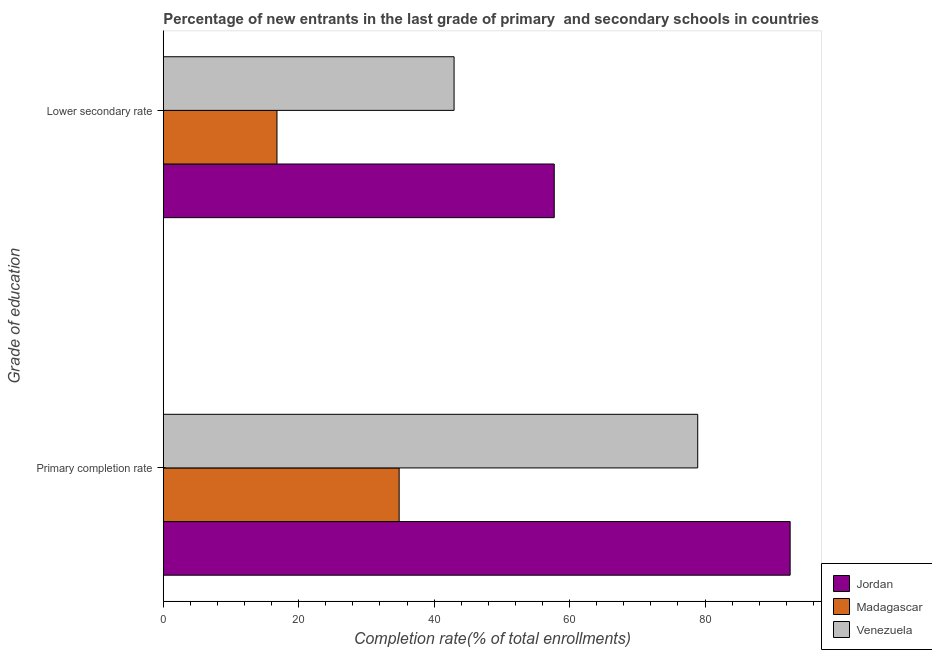How many groups of bars are there?
Provide a short and direct response. 2. What is the label of the 2nd group of bars from the top?
Give a very brief answer. Primary completion rate. What is the completion rate in secondary schools in Madagascar?
Ensure brevity in your answer.  16.79. Across all countries, what is the maximum completion rate in secondary schools?
Offer a terse response. 57.74. Across all countries, what is the minimum completion rate in secondary schools?
Your response must be concise. 16.79. In which country was the completion rate in secondary schools maximum?
Provide a short and direct response. Jordan. In which country was the completion rate in secondary schools minimum?
Ensure brevity in your answer.  Madagascar. What is the total completion rate in secondary schools in the graph?
Offer a terse response. 117.48. What is the difference between the completion rate in primary schools in Jordan and that in Madagascar?
Ensure brevity in your answer.  57.74. What is the difference between the completion rate in primary schools in Jordan and the completion rate in secondary schools in Venezuela?
Keep it short and to the point. 49.63. What is the average completion rate in primary schools per country?
Provide a succinct answer. 68.78. What is the difference between the completion rate in primary schools and completion rate in secondary schools in Venezuela?
Your response must be concise. 35.98. What is the ratio of the completion rate in primary schools in Madagascar to that in Jordan?
Give a very brief answer. 0.38. What does the 2nd bar from the top in Lower secondary rate represents?
Ensure brevity in your answer.  Madagascar. What does the 3rd bar from the bottom in Lower secondary rate represents?
Provide a short and direct response. Venezuela. How many bars are there?
Ensure brevity in your answer.  6. What is the difference between two consecutive major ticks on the X-axis?
Provide a succinct answer. 20. Are the values on the major ticks of X-axis written in scientific E-notation?
Provide a succinct answer. No. Does the graph contain any zero values?
Your answer should be compact. No. How are the legend labels stacked?
Your answer should be compact. Vertical. What is the title of the graph?
Provide a short and direct response. Percentage of new entrants in the last grade of primary  and secondary schools in countries. What is the label or title of the X-axis?
Ensure brevity in your answer.  Completion rate(% of total enrollments). What is the label or title of the Y-axis?
Your answer should be very brief. Grade of education. What is the Completion rate(% of total enrollments) in Jordan in Primary completion rate?
Your response must be concise. 92.57. What is the Completion rate(% of total enrollments) in Madagascar in Primary completion rate?
Your answer should be compact. 34.84. What is the Completion rate(% of total enrollments) in Venezuela in Primary completion rate?
Ensure brevity in your answer.  78.92. What is the Completion rate(% of total enrollments) of Jordan in Lower secondary rate?
Give a very brief answer. 57.74. What is the Completion rate(% of total enrollments) of Madagascar in Lower secondary rate?
Offer a very short reply. 16.79. What is the Completion rate(% of total enrollments) of Venezuela in Lower secondary rate?
Ensure brevity in your answer.  42.94. Across all Grade of education, what is the maximum Completion rate(% of total enrollments) of Jordan?
Provide a succinct answer. 92.57. Across all Grade of education, what is the maximum Completion rate(% of total enrollments) of Madagascar?
Make the answer very short. 34.84. Across all Grade of education, what is the maximum Completion rate(% of total enrollments) in Venezuela?
Ensure brevity in your answer.  78.92. Across all Grade of education, what is the minimum Completion rate(% of total enrollments) of Jordan?
Ensure brevity in your answer.  57.74. Across all Grade of education, what is the minimum Completion rate(% of total enrollments) in Madagascar?
Make the answer very short. 16.79. Across all Grade of education, what is the minimum Completion rate(% of total enrollments) of Venezuela?
Make the answer very short. 42.94. What is the total Completion rate(% of total enrollments) of Jordan in the graph?
Keep it short and to the point. 150.31. What is the total Completion rate(% of total enrollments) in Madagascar in the graph?
Give a very brief answer. 51.63. What is the total Completion rate(% of total enrollments) in Venezuela in the graph?
Keep it short and to the point. 121.87. What is the difference between the Completion rate(% of total enrollments) of Jordan in Primary completion rate and that in Lower secondary rate?
Ensure brevity in your answer.  34.84. What is the difference between the Completion rate(% of total enrollments) of Madagascar in Primary completion rate and that in Lower secondary rate?
Your answer should be compact. 18.04. What is the difference between the Completion rate(% of total enrollments) of Venezuela in Primary completion rate and that in Lower secondary rate?
Provide a short and direct response. 35.98. What is the difference between the Completion rate(% of total enrollments) of Jordan in Primary completion rate and the Completion rate(% of total enrollments) of Madagascar in Lower secondary rate?
Your response must be concise. 75.78. What is the difference between the Completion rate(% of total enrollments) in Jordan in Primary completion rate and the Completion rate(% of total enrollments) in Venezuela in Lower secondary rate?
Ensure brevity in your answer.  49.63. What is the difference between the Completion rate(% of total enrollments) of Madagascar in Primary completion rate and the Completion rate(% of total enrollments) of Venezuela in Lower secondary rate?
Offer a very short reply. -8.11. What is the average Completion rate(% of total enrollments) in Jordan per Grade of education?
Give a very brief answer. 75.16. What is the average Completion rate(% of total enrollments) in Madagascar per Grade of education?
Your response must be concise. 25.81. What is the average Completion rate(% of total enrollments) of Venezuela per Grade of education?
Your response must be concise. 60.93. What is the difference between the Completion rate(% of total enrollments) in Jordan and Completion rate(% of total enrollments) in Madagascar in Primary completion rate?
Your response must be concise. 57.74. What is the difference between the Completion rate(% of total enrollments) of Jordan and Completion rate(% of total enrollments) of Venezuela in Primary completion rate?
Your response must be concise. 13.65. What is the difference between the Completion rate(% of total enrollments) in Madagascar and Completion rate(% of total enrollments) in Venezuela in Primary completion rate?
Provide a short and direct response. -44.09. What is the difference between the Completion rate(% of total enrollments) of Jordan and Completion rate(% of total enrollments) of Madagascar in Lower secondary rate?
Keep it short and to the point. 40.94. What is the difference between the Completion rate(% of total enrollments) of Jordan and Completion rate(% of total enrollments) of Venezuela in Lower secondary rate?
Your answer should be compact. 14.79. What is the difference between the Completion rate(% of total enrollments) of Madagascar and Completion rate(% of total enrollments) of Venezuela in Lower secondary rate?
Provide a succinct answer. -26.15. What is the ratio of the Completion rate(% of total enrollments) of Jordan in Primary completion rate to that in Lower secondary rate?
Your response must be concise. 1.6. What is the ratio of the Completion rate(% of total enrollments) in Madagascar in Primary completion rate to that in Lower secondary rate?
Keep it short and to the point. 2.07. What is the ratio of the Completion rate(% of total enrollments) in Venezuela in Primary completion rate to that in Lower secondary rate?
Provide a short and direct response. 1.84. What is the difference between the highest and the second highest Completion rate(% of total enrollments) in Jordan?
Your answer should be very brief. 34.84. What is the difference between the highest and the second highest Completion rate(% of total enrollments) of Madagascar?
Your answer should be compact. 18.04. What is the difference between the highest and the second highest Completion rate(% of total enrollments) in Venezuela?
Ensure brevity in your answer.  35.98. What is the difference between the highest and the lowest Completion rate(% of total enrollments) in Jordan?
Your answer should be very brief. 34.84. What is the difference between the highest and the lowest Completion rate(% of total enrollments) in Madagascar?
Offer a terse response. 18.04. What is the difference between the highest and the lowest Completion rate(% of total enrollments) of Venezuela?
Make the answer very short. 35.98. 